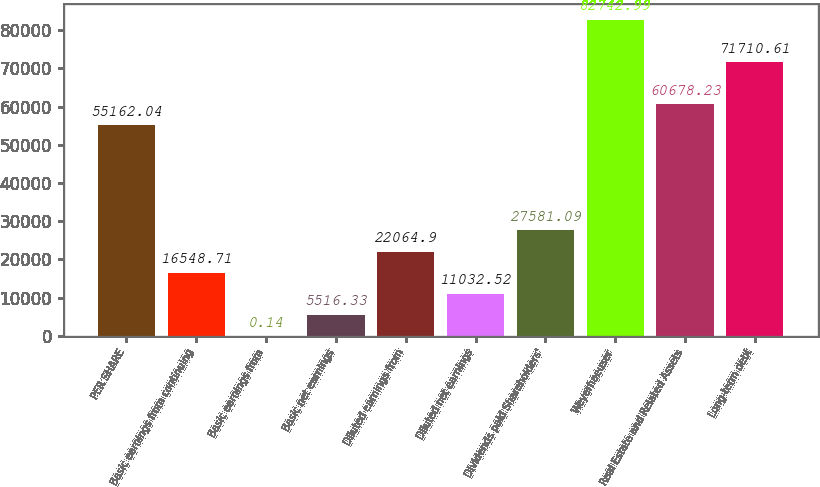Convert chart. <chart><loc_0><loc_0><loc_500><loc_500><bar_chart><fcel>PER SHARE<fcel>Basic earnings from continuing<fcel>Basic earnings from<fcel>Basic net earnings<fcel>Diluted earnings from<fcel>Diluted net earnings<fcel>Dividends paid Shareholders'<fcel>Weyerhaeuser<fcel>Real Estate and Related Assets<fcel>Long-term debt<nl><fcel>55162<fcel>16548.7<fcel>0.14<fcel>5516.33<fcel>22064.9<fcel>11032.5<fcel>27581.1<fcel>82743<fcel>60678.2<fcel>71710.6<nl></chart> 